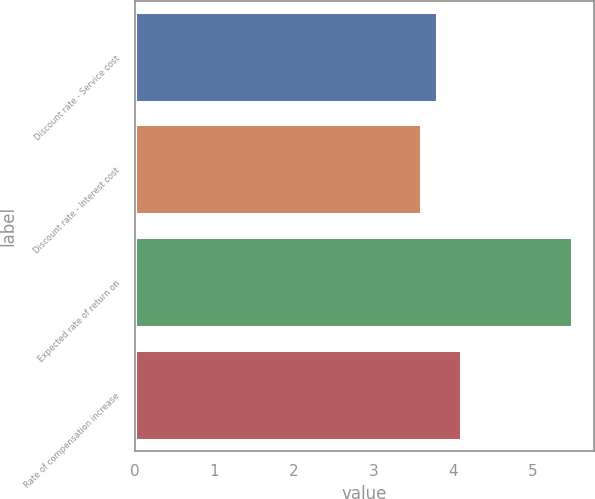Convert chart to OTSL. <chart><loc_0><loc_0><loc_500><loc_500><bar_chart><fcel>Discount rate - Service cost<fcel>Discount rate - Interest cost<fcel>Expected rate of return on<fcel>Rate of compensation increase<nl><fcel>3.8<fcel>3.6<fcel>5.5<fcel>4.1<nl></chart> 